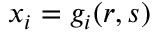<formula> <loc_0><loc_0><loc_500><loc_500>x _ { i } = g _ { i } ( r , s )</formula> 